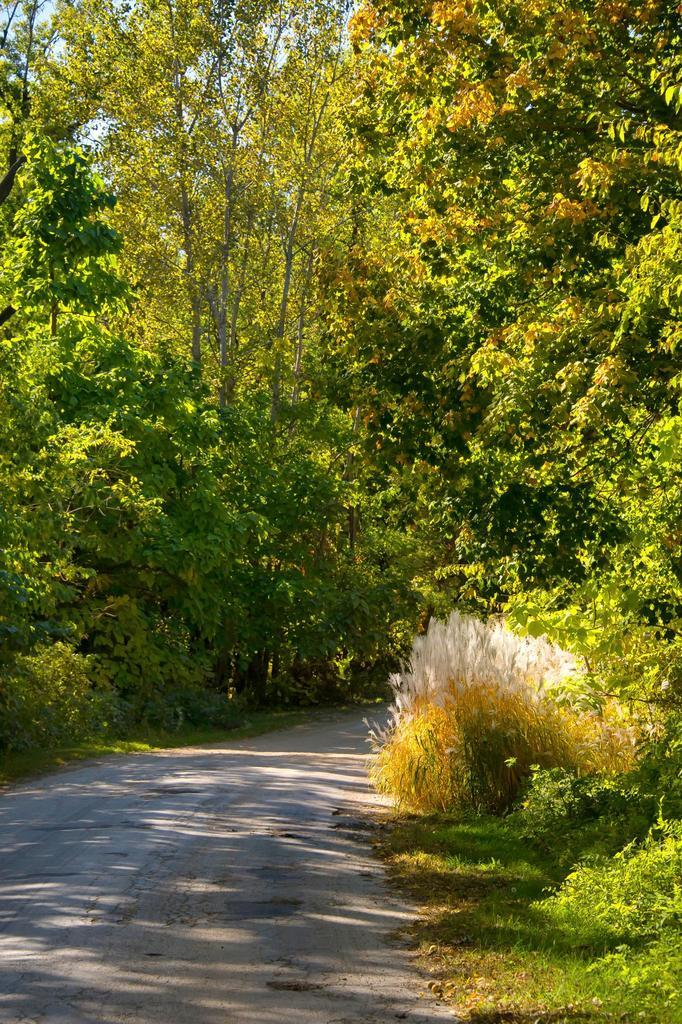What is the main feature of the image? There is a road in the image. What else can be seen alongside the road? There are trees in the image. What can be seen in the distance in the image? The sky is visible in the background of the image. What type of sand can be seen on the road in the image? There is no sand present on the road in the image. 